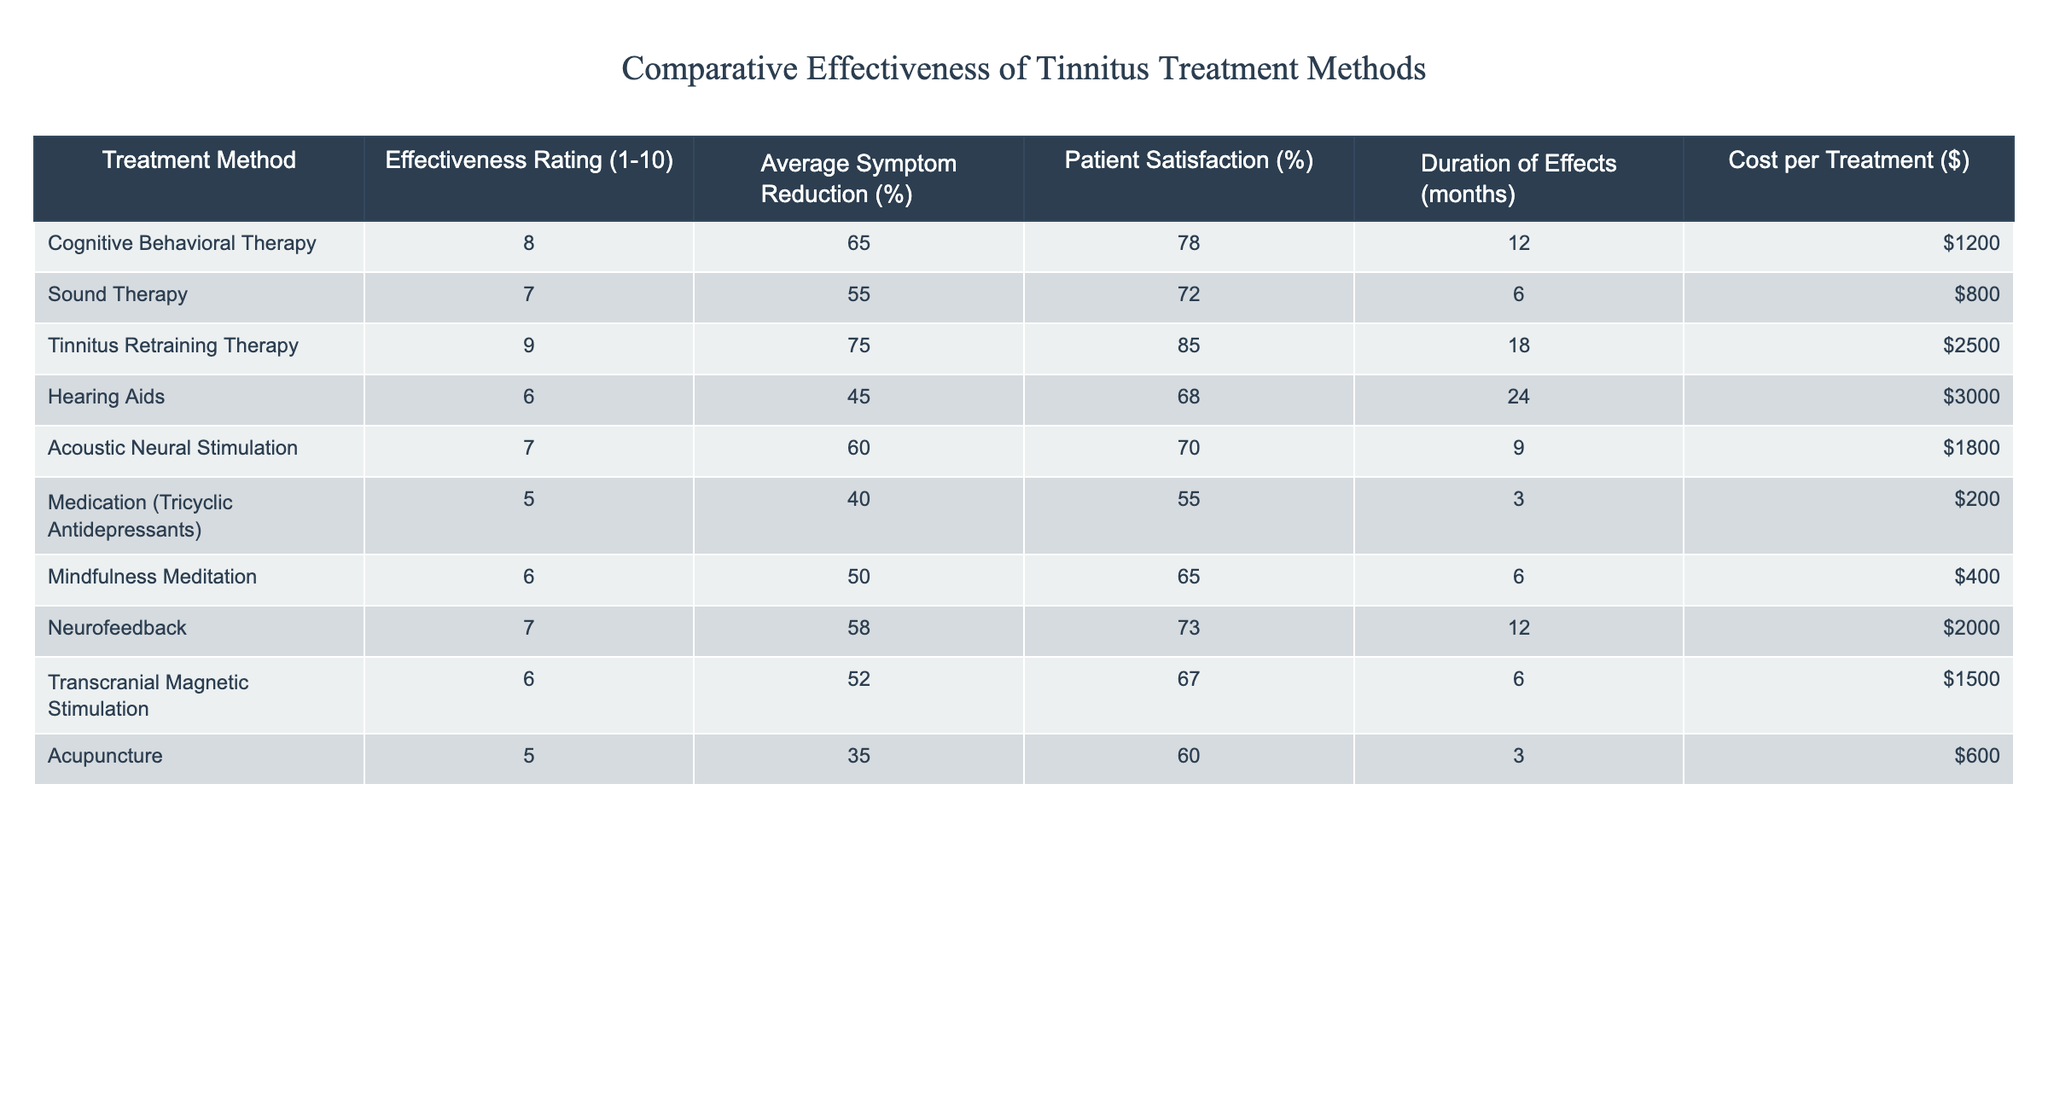What is the effectiveness rating of Cognitive Behavioral Therapy? The effectiveness rating for Cognitive Behavioral Therapy is listed in the table under "Effectiveness Rating," which shows a value of 8.
Answer: 8 Which treatment method has the highest average symptom reduction percentage? By examining the "Average Symptom Reduction (%)" column, the treatment method with the highest value is Tinnitus Retraining Therapy, which shows a reduction of 75%.
Answer: Tinnitus Retraining Therapy What is the cost per treatment for Acupuncture? The cost per treatment for Acupuncture can be found in the "Cost per Treatment ($)" column, where it is listed as $600.
Answer: $600 Is the average symptom reduction for Hearing Aids higher than for Mindfulness Meditation? Looking at the "Average Symptom Reduction (%)" for Hearing Aids, which is 45%, and Mindfulness Meditation, which is 50%, we find that 50% is higher than 45%. Therefore, the statement is true.
Answer: Yes What is the average cost of the treatments listed in the table? To find the average cost, sum up all costs: 1200 + 800 + 2500 + 3000 + 1800 + 200 + 400 + 2000 + 1500 + 600 = 13600. There are 10 treatments, so 13600 / 10 = 1360.
Answer: $1360 How many treatment methods have a duration of effects longer than 12 months? By checking the "Duration of Effects (months)" column, we count the methods with durations of 18 and 24 months (Tinnitus Retraining Therapy and Hearing Aids). Thus, there are 2 methods.
Answer: 2 Which treatment method has both the highest effectiveness rating and the highest patient satisfaction percentage? The only treatment that has both the highest effectiveness rating (9) and patient satisfaction percentage (85%) is Tinnitus Retraining Therapy.
Answer: Tinnitus Retraining Therapy Which treatment methods have a patient satisfaction percentage greater than 70%? Looking at the "Patient Satisfaction (%)" column, Tinnitus Retraining Therapy (85%), Neurofeedback (73%), and Sound Therapy (72%) all have percentages greater than 70%.
Answer: Tinnitus Retraining Therapy, Neurofeedback, Sound Therapy What is the difference in average symptom reduction between Sound Therapy and Medication? The average symptom reduction for Sound Therapy is 55%, and for Medication, it is 40%. Therefore, the difference is 55% - 40% = 15%.
Answer: 15% If the effectiveness rating of Tinnitus Retraining Therapy were to decrease by 1 point, what would be its new effectiveness rating? The current effectiveness rating for Tinnitus Retraining Therapy is 9. If it decreases by 1 point, the new rating would be 9 - 1 = 8.
Answer: 8 